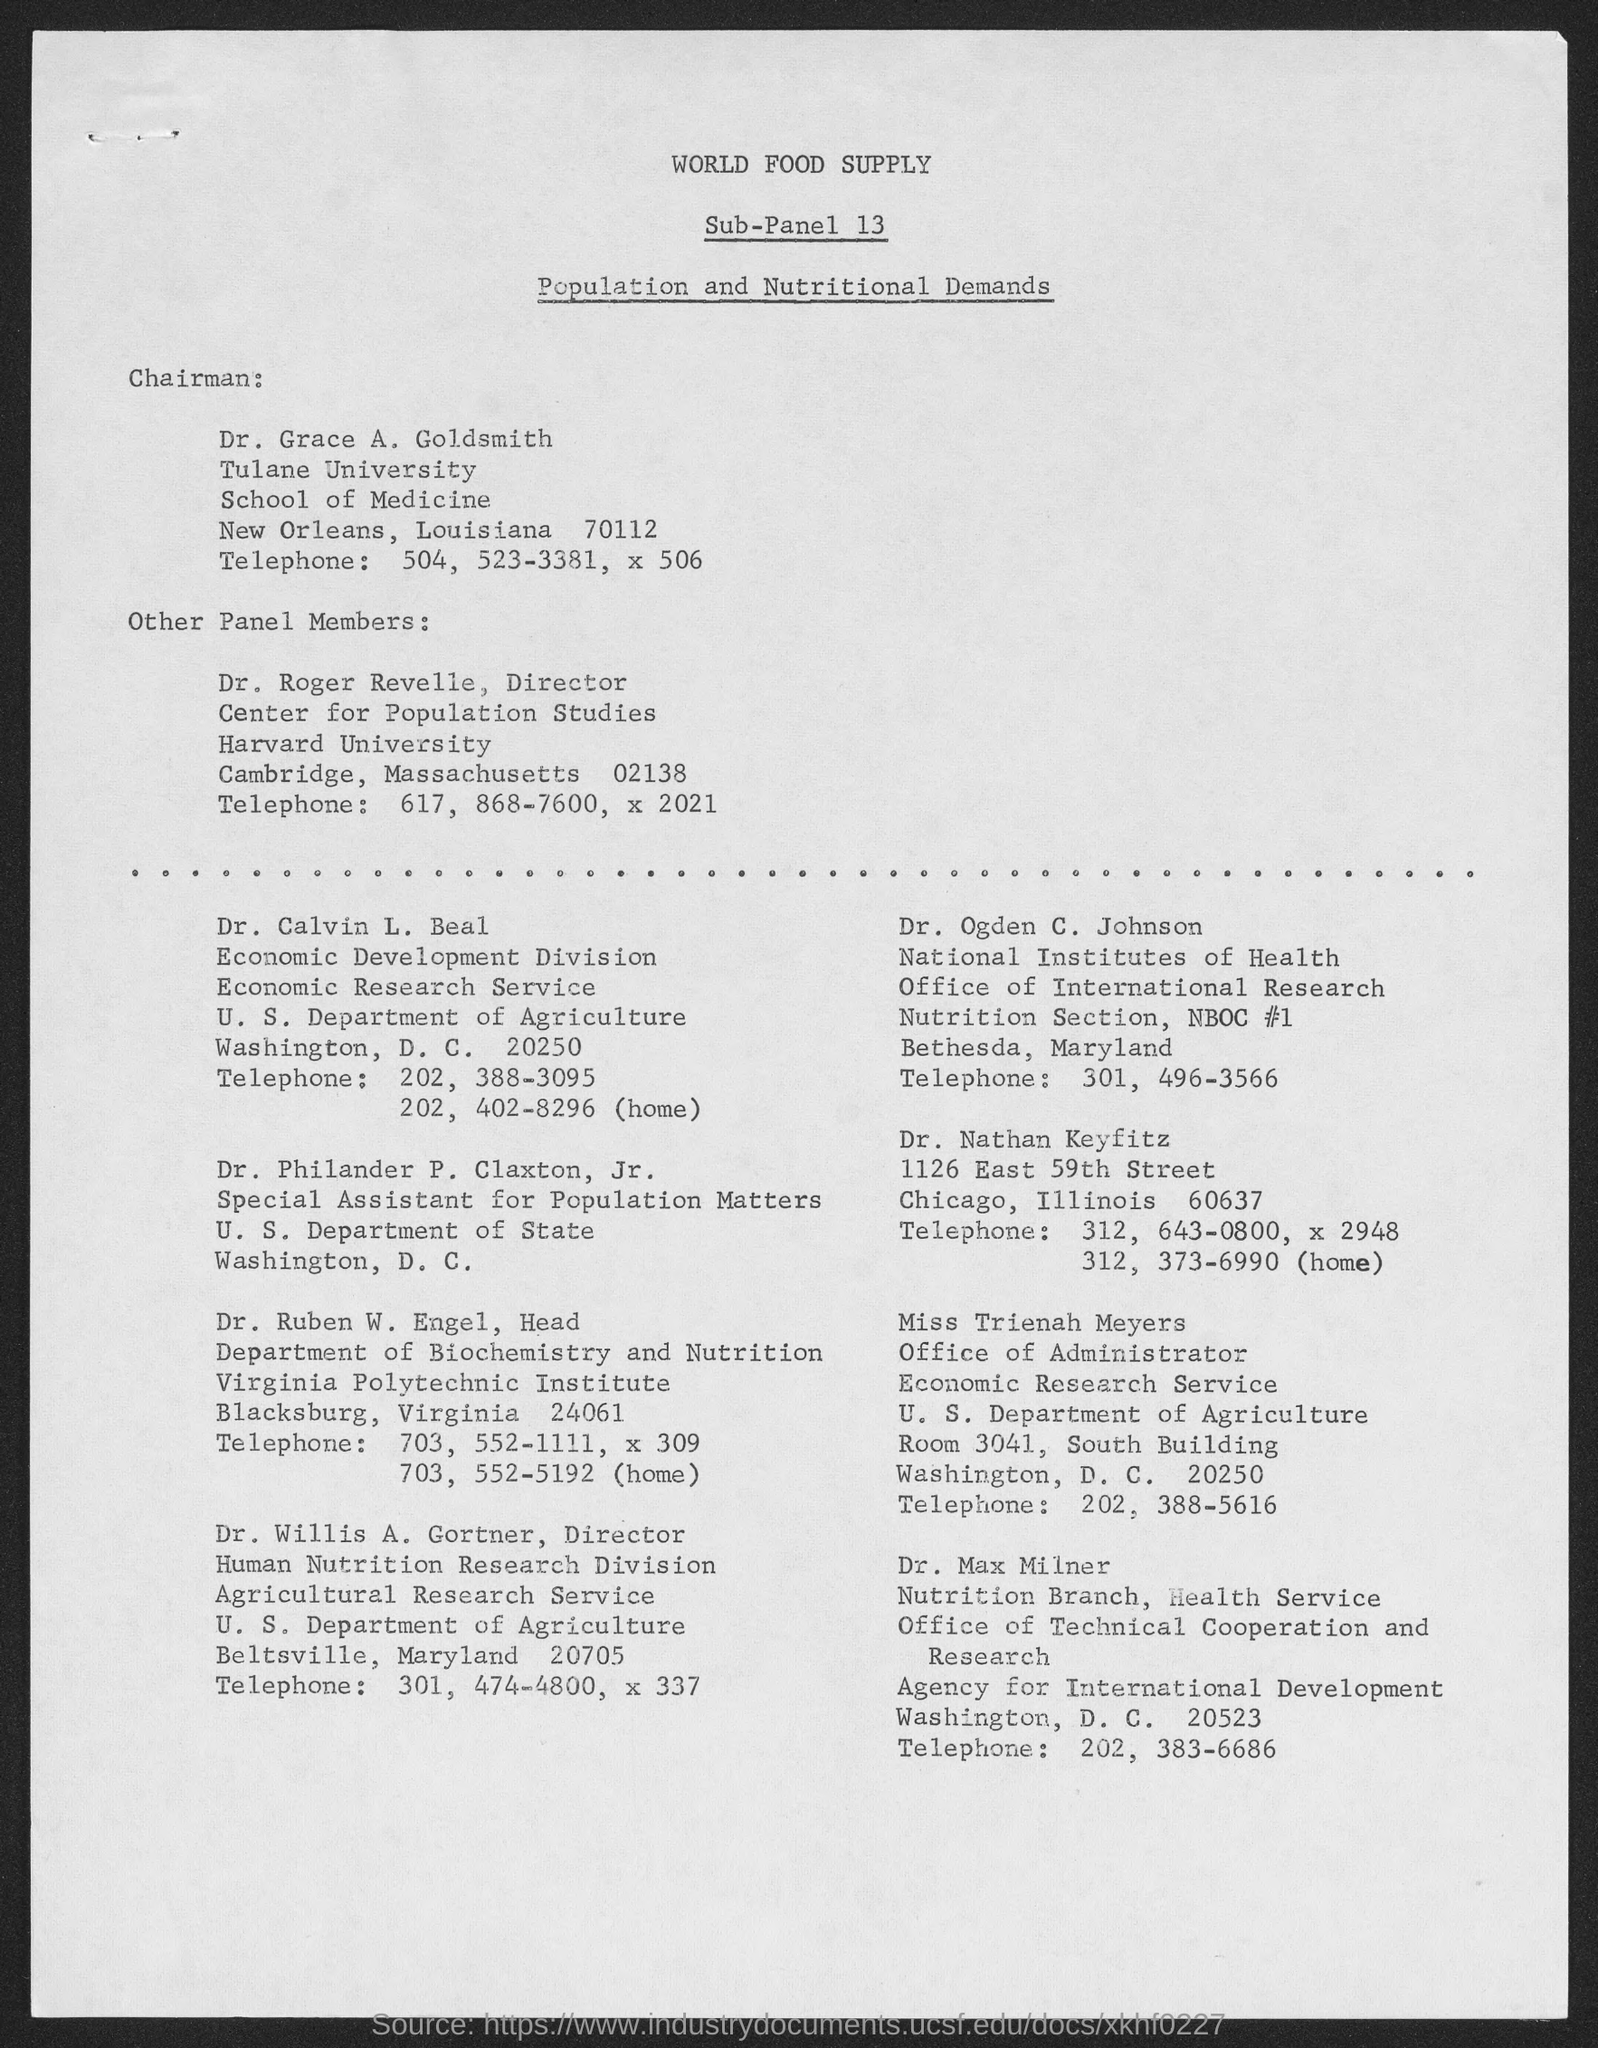Who is the Chairman?
Give a very brief answer. Dr. Grace A. Goldsmith. 